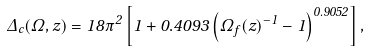<formula> <loc_0><loc_0><loc_500><loc_500>\Delta _ { c } ( \Omega , z ) = 1 8 \pi ^ { 2 } \left [ 1 + 0 . 4 0 9 3 \left ( \Omega _ { f } ( z ) ^ { - 1 } - 1 \right ) ^ { 0 . 9 0 5 2 } \right ] ,</formula> 